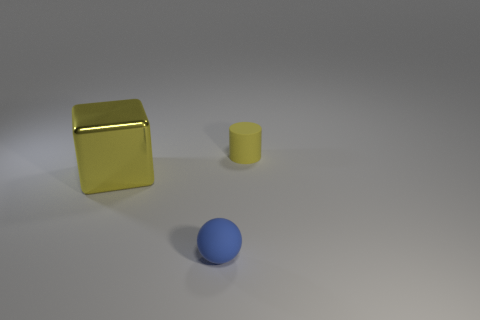What color is the matte object that is to the left of the small object that is right of the small matte thing that is in front of the big yellow thing?
Ensure brevity in your answer.  Blue. What number of cylinders have the same size as the blue rubber ball?
Give a very brief answer. 1. What number of small yellow cylinders are there?
Give a very brief answer. 1. Is the small ball made of the same material as the yellow object left of the small yellow matte object?
Offer a terse response. No. What number of yellow objects are either spheres or matte cylinders?
Offer a terse response. 1. There is a yellow cylinder that is the same material as the blue thing; what size is it?
Make the answer very short. Small. What number of other big objects are the same shape as the blue matte thing?
Make the answer very short. 0. Are there more yellow objects that are to the right of the small blue ball than yellow shiny cubes that are right of the cube?
Ensure brevity in your answer.  Yes. Does the metallic object have the same color as the rubber thing behind the blue object?
Provide a succinct answer. Yes. There is a yellow cylinder that is the same size as the sphere; what is its material?
Ensure brevity in your answer.  Rubber. 